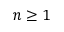Convert formula to latex. <formula><loc_0><loc_0><loc_500><loc_500>n \geq 1</formula> 